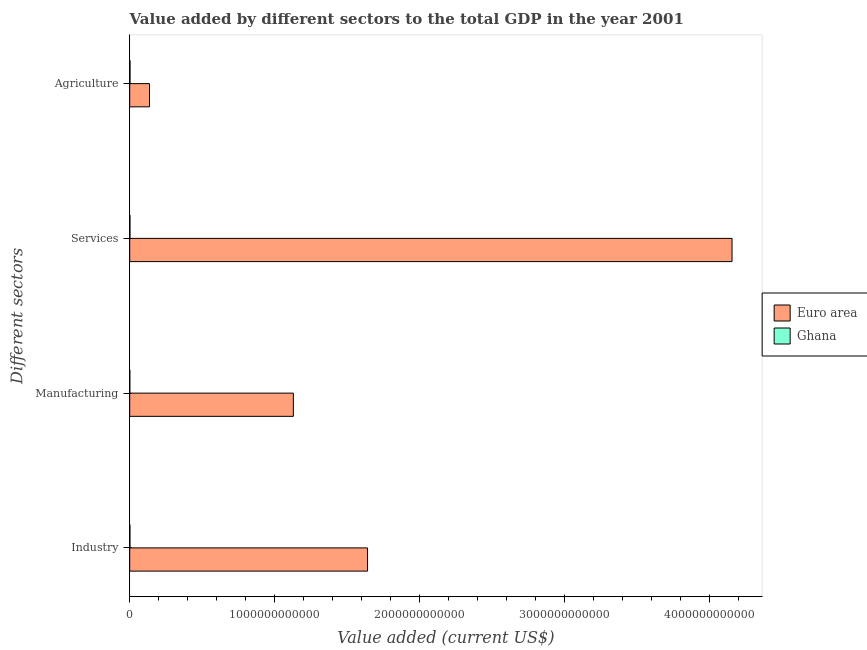How many different coloured bars are there?
Make the answer very short. 2. How many groups of bars are there?
Your response must be concise. 4. Are the number of bars on each tick of the Y-axis equal?
Offer a terse response. Yes. How many bars are there on the 4th tick from the top?
Your response must be concise. 2. What is the label of the 4th group of bars from the top?
Provide a succinct answer. Industry. What is the value added by manufacturing sector in Euro area?
Your answer should be very brief. 1.13e+12. Across all countries, what is the maximum value added by manufacturing sector?
Keep it short and to the point. 1.13e+12. Across all countries, what is the minimum value added by industrial sector?
Keep it short and to the point. 1.34e+09. What is the total value added by agricultural sector in the graph?
Give a very brief answer. 1.38e+11. What is the difference between the value added by industrial sector in Ghana and that in Euro area?
Ensure brevity in your answer.  -1.64e+12. What is the difference between the value added by industrial sector in Euro area and the value added by manufacturing sector in Ghana?
Provide a short and direct response. 1.64e+12. What is the average value added by manufacturing sector per country?
Provide a succinct answer. 5.65e+11. What is the difference between the value added by agricultural sector and value added by industrial sector in Euro area?
Provide a succinct answer. -1.51e+12. What is the ratio of the value added by industrial sector in Euro area to that in Ghana?
Ensure brevity in your answer.  1224.95. Is the value added by services sector in Euro area less than that in Ghana?
Ensure brevity in your answer.  No. What is the difference between the highest and the second highest value added by manufacturing sector?
Your answer should be very brief. 1.13e+12. What is the difference between the highest and the lowest value added by manufacturing sector?
Make the answer very short. 1.13e+12. Is the sum of the value added by agricultural sector in Euro area and Ghana greater than the maximum value added by industrial sector across all countries?
Keep it short and to the point. No. Is it the case that in every country, the sum of the value added by agricultural sector and value added by services sector is greater than the sum of value added by manufacturing sector and value added by industrial sector?
Offer a very short reply. No. What does the 2nd bar from the top in Industry represents?
Ensure brevity in your answer.  Euro area. What does the 2nd bar from the bottom in Agriculture represents?
Provide a succinct answer. Ghana. How many bars are there?
Give a very brief answer. 8. How many countries are there in the graph?
Offer a very short reply. 2. What is the difference between two consecutive major ticks on the X-axis?
Your response must be concise. 1.00e+12. Are the values on the major ticks of X-axis written in scientific E-notation?
Provide a succinct answer. No. Does the graph contain any zero values?
Offer a terse response. No. Where does the legend appear in the graph?
Offer a terse response. Center right. How are the legend labels stacked?
Ensure brevity in your answer.  Vertical. What is the title of the graph?
Your response must be concise. Value added by different sectors to the total GDP in the year 2001. What is the label or title of the X-axis?
Ensure brevity in your answer.  Value added (current US$). What is the label or title of the Y-axis?
Provide a short and direct response. Different sectors. What is the Value added (current US$) of Euro area in Industry?
Offer a terse response. 1.64e+12. What is the Value added (current US$) in Ghana in Industry?
Your answer should be very brief. 1.34e+09. What is the Value added (current US$) in Euro area in Manufacturing?
Offer a very short reply. 1.13e+12. What is the Value added (current US$) of Ghana in Manufacturing?
Your answer should be very brief. 4.79e+08. What is the Value added (current US$) in Euro area in Services?
Your response must be concise. 4.16e+12. What is the Value added (current US$) in Ghana in Services?
Offer a very short reply. 1.55e+09. What is the Value added (current US$) of Euro area in Agriculture?
Provide a succinct answer. 1.36e+11. What is the Value added (current US$) in Ghana in Agriculture?
Make the answer very short. 1.87e+09. Across all Different sectors, what is the maximum Value added (current US$) of Euro area?
Give a very brief answer. 4.16e+12. Across all Different sectors, what is the maximum Value added (current US$) in Ghana?
Make the answer very short. 1.87e+09. Across all Different sectors, what is the minimum Value added (current US$) of Euro area?
Make the answer very short. 1.36e+11. Across all Different sectors, what is the minimum Value added (current US$) of Ghana?
Keep it short and to the point. 4.79e+08. What is the total Value added (current US$) in Euro area in the graph?
Offer a very short reply. 7.07e+12. What is the total Value added (current US$) in Ghana in the graph?
Provide a short and direct response. 5.24e+09. What is the difference between the Value added (current US$) in Euro area in Industry and that in Manufacturing?
Offer a very short reply. 5.12e+11. What is the difference between the Value added (current US$) in Ghana in Industry and that in Manufacturing?
Keep it short and to the point. 8.62e+08. What is the difference between the Value added (current US$) of Euro area in Industry and that in Services?
Keep it short and to the point. -2.52e+12. What is the difference between the Value added (current US$) in Ghana in Industry and that in Services?
Your answer should be very brief. -2.10e+08. What is the difference between the Value added (current US$) in Euro area in Industry and that in Agriculture?
Keep it short and to the point. 1.51e+12. What is the difference between the Value added (current US$) in Ghana in Industry and that in Agriculture?
Give a very brief answer. -5.33e+08. What is the difference between the Value added (current US$) in Euro area in Manufacturing and that in Services?
Make the answer very short. -3.03e+12. What is the difference between the Value added (current US$) of Ghana in Manufacturing and that in Services?
Your response must be concise. -1.07e+09. What is the difference between the Value added (current US$) in Euro area in Manufacturing and that in Agriculture?
Provide a short and direct response. 9.93e+11. What is the difference between the Value added (current US$) in Ghana in Manufacturing and that in Agriculture?
Ensure brevity in your answer.  -1.39e+09. What is the difference between the Value added (current US$) in Euro area in Services and that in Agriculture?
Keep it short and to the point. 4.02e+12. What is the difference between the Value added (current US$) of Ghana in Services and that in Agriculture?
Your answer should be very brief. -3.23e+08. What is the difference between the Value added (current US$) in Euro area in Industry and the Value added (current US$) in Ghana in Manufacturing?
Make the answer very short. 1.64e+12. What is the difference between the Value added (current US$) of Euro area in Industry and the Value added (current US$) of Ghana in Services?
Your answer should be very brief. 1.64e+12. What is the difference between the Value added (current US$) in Euro area in Industry and the Value added (current US$) in Ghana in Agriculture?
Your response must be concise. 1.64e+12. What is the difference between the Value added (current US$) in Euro area in Manufacturing and the Value added (current US$) in Ghana in Services?
Your response must be concise. 1.13e+12. What is the difference between the Value added (current US$) of Euro area in Manufacturing and the Value added (current US$) of Ghana in Agriculture?
Offer a terse response. 1.13e+12. What is the difference between the Value added (current US$) in Euro area in Services and the Value added (current US$) in Ghana in Agriculture?
Make the answer very short. 4.16e+12. What is the average Value added (current US$) of Euro area per Different sectors?
Your response must be concise. 1.77e+12. What is the average Value added (current US$) in Ghana per Different sectors?
Give a very brief answer. 1.31e+09. What is the difference between the Value added (current US$) of Euro area and Value added (current US$) of Ghana in Industry?
Your answer should be very brief. 1.64e+12. What is the difference between the Value added (current US$) in Euro area and Value added (current US$) in Ghana in Manufacturing?
Provide a succinct answer. 1.13e+12. What is the difference between the Value added (current US$) of Euro area and Value added (current US$) of Ghana in Services?
Offer a terse response. 4.16e+12. What is the difference between the Value added (current US$) in Euro area and Value added (current US$) in Ghana in Agriculture?
Give a very brief answer. 1.35e+11. What is the ratio of the Value added (current US$) in Euro area in Industry to that in Manufacturing?
Your response must be concise. 1.45. What is the ratio of the Value added (current US$) of Ghana in Industry to that in Manufacturing?
Give a very brief answer. 2.8. What is the ratio of the Value added (current US$) of Euro area in Industry to that in Services?
Give a very brief answer. 0.39. What is the ratio of the Value added (current US$) in Ghana in Industry to that in Services?
Provide a succinct answer. 0.86. What is the ratio of the Value added (current US$) in Euro area in Industry to that in Agriculture?
Provide a short and direct response. 12.03. What is the ratio of the Value added (current US$) in Ghana in Industry to that in Agriculture?
Offer a very short reply. 0.72. What is the ratio of the Value added (current US$) in Euro area in Manufacturing to that in Services?
Offer a terse response. 0.27. What is the ratio of the Value added (current US$) of Ghana in Manufacturing to that in Services?
Provide a succinct answer. 0.31. What is the ratio of the Value added (current US$) of Euro area in Manufacturing to that in Agriculture?
Your response must be concise. 8.28. What is the ratio of the Value added (current US$) in Ghana in Manufacturing to that in Agriculture?
Your answer should be compact. 0.26. What is the ratio of the Value added (current US$) in Euro area in Services to that in Agriculture?
Keep it short and to the point. 30.46. What is the ratio of the Value added (current US$) of Ghana in Services to that in Agriculture?
Your answer should be very brief. 0.83. What is the difference between the highest and the second highest Value added (current US$) of Euro area?
Keep it short and to the point. 2.52e+12. What is the difference between the highest and the second highest Value added (current US$) in Ghana?
Your answer should be compact. 3.23e+08. What is the difference between the highest and the lowest Value added (current US$) of Euro area?
Offer a very short reply. 4.02e+12. What is the difference between the highest and the lowest Value added (current US$) in Ghana?
Ensure brevity in your answer.  1.39e+09. 